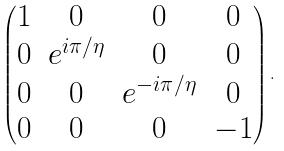Convert formula to latex. <formula><loc_0><loc_0><loc_500><loc_500>\left ( \begin{matrix} 1 & 0 & 0 & 0 \\ 0 & e ^ { i \pi / \eta } & 0 & 0 \\ 0 & 0 & e ^ { - i \pi / \eta } & 0 \\ 0 & 0 & 0 & - 1 \end{matrix} \right ) .</formula> 